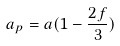<formula> <loc_0><loc_0><loc_500><loc_500>a _ { p } = a ( 1 - \frac { 2 f } { 3 } )</formula> 